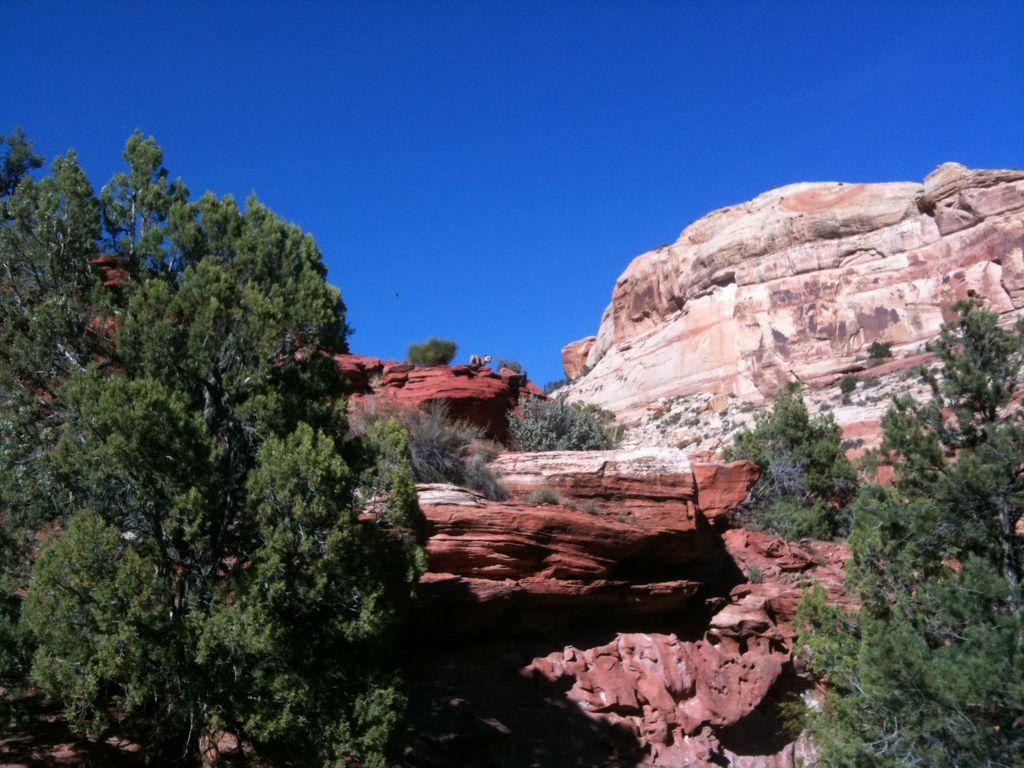What type of natural features can be seen in the image? There are trees and mountains in the image. What part of the natural environment is visible in the image? The sky is visible in the image. When was the image taken, based on the information provided? The image was taken during the day. What type of gold can be seen in the image? There is no gold present in the image; it features trees, mountains, and the sky. How does the loss of a loved one affect the image? The image does not depict any loss or emotional context, so it cannot be determined how the loss of a loved one might affect the image. 